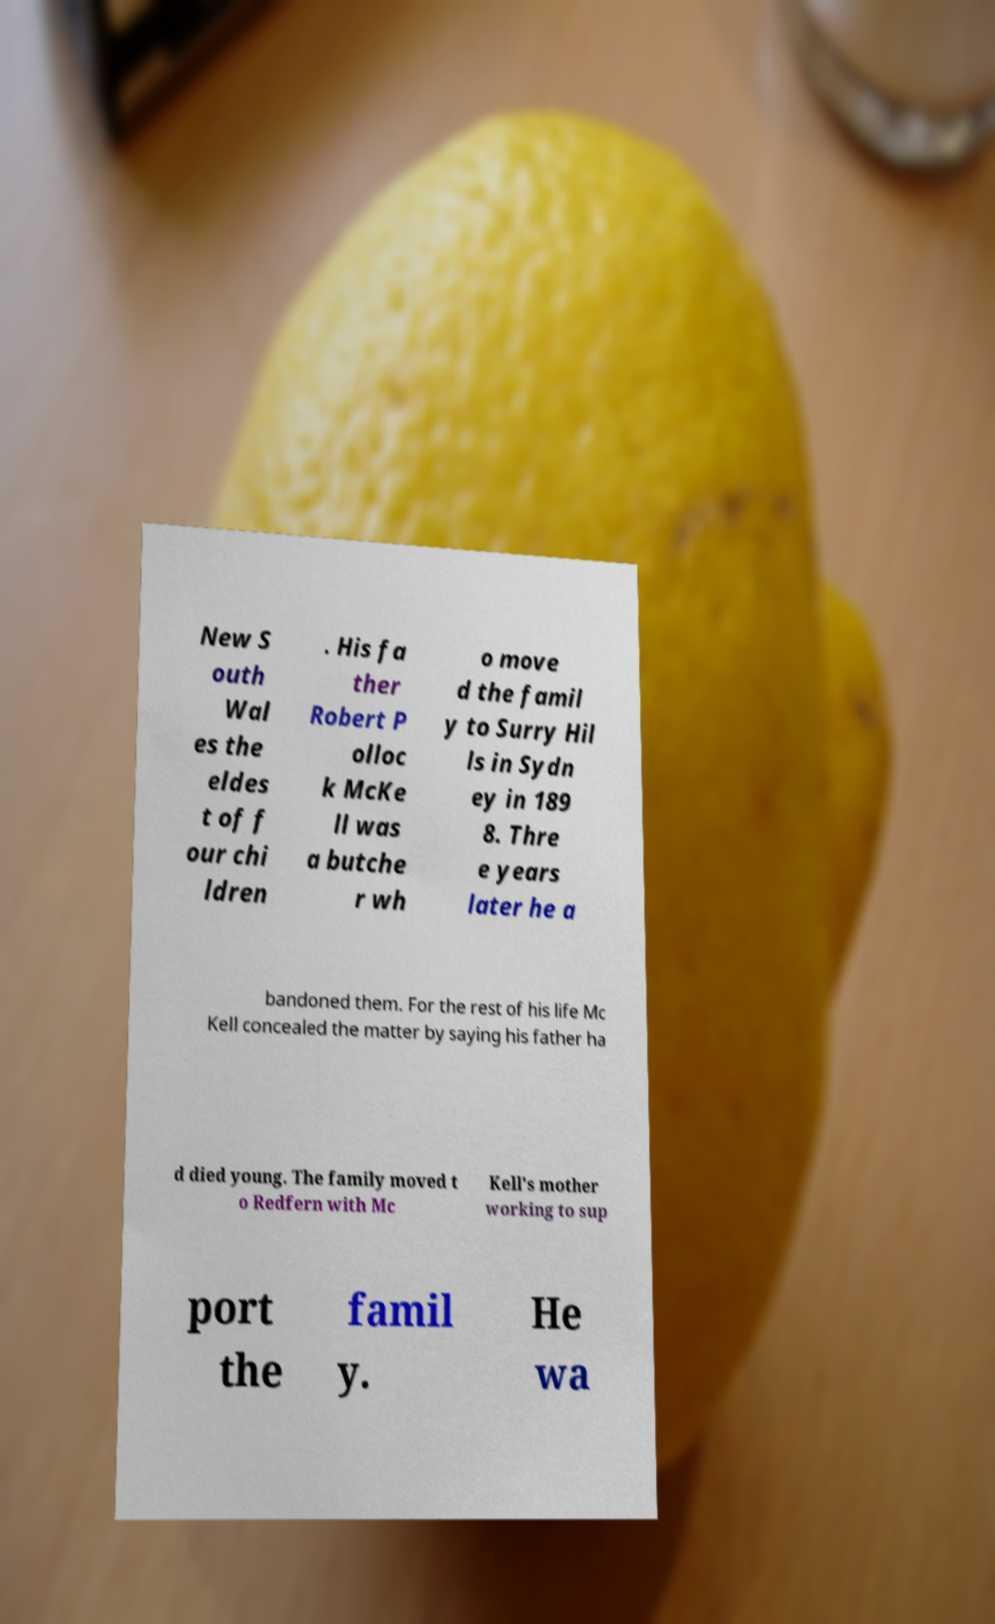There's text embedded in this image that I need extracted. Can you transcribe it verbatim? New S outh Wal es the eldes t of f our chi ldren . His fa ther Robert P olloc k McKe ll was a butche r wh o move d the famil y to Surry Hil ls in Sydn ey in 189 8. Thre e years later he a bandoned them. For the rest of his life Mc Kell concealed the matter by saying his father ha d died young. The family moved t o Redfern with Mc Kell's mother working to sup port the famil y. He wa 